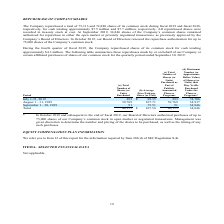From Amcon Distributing's financial document, How many shares of its common stock did the company repurchase in fiscal 2019 and fiscal 2018, respectively? The document shows two values: 75,113 and 74,880. From the document: "The Company repurchased a total of 75,113 and 74,880 shares of its common stock during fiscal 2019 and fiscal 2018, respectively, for cash totaling ap..." Also, How much did the company pay to repurchase shares of its common stock during fiscal 2019 and fiscal 2018, respectively? The document shows two values: $7.5 million and $7.7 million. From the document: ", for cash totaling approximately $7.5 million and $7.7 million, respectively. All repurchased shares were recorded in treasury stock at cost. At Sept..." Also, What is the total number of shares purchased by the company in August and September 2019 respectively? The document shows two values: 39,769 and 91. From the document: "August 1 - 31, 2019 39,769 107.71 39,769 34,937 September 1 - 30, 2019 91 75.51 91 34,846 Total 40,153 $ 107.58 40,153 34,846..." Also, can you calculate: What is the percentage change in the shares of common stock repurchased between fiscal 2018 and 2019? To answer this question, I need to perform calculations using the financial data. The calculation is: (75,113 - 74,880)/74,880 , which equals 0.31 (percentage). This is based on the information: "The Company repurchased a total of 75,113 and 74,880 shares of its common stock during fiscal 2019 and fiscal 2018, respectively, for cash totaling appr The Company repurchased a total of 75,113 and 7..." The key data points involved are: 74,880, 75,113. Also, can you calculate: What is the percentage change in the amount paid by the company to purchase its common stock during 2018 and 2019? To answer this question, I need to perform calculations using the financial data. The calculation is: (7.5 - 7.7)/7.7 , which equals -2.6 (percentage). This is based on the information: "for cash totaling approximately $7.5 million and $7.7 million, respectively. All repurchased shares were recorded in treasury stock at cost. At September 8, respectively, for cash totaling approximate..." The key data points involved are: 7.5, 7.7. Also, can you calculate: What is the percentage change in the number of shares (or units) purchased by the company between August and September 2019? To answer this question, I need to perform calculations using the financial data. The calculation is: (91 - 39,769)/39,769 , which equals -99.77 (percentage). This is based on the information: "August 1 - 31, 2019 39,769 107.71 39,769 34,937 September 1 - 30, 2019 91 75.51 91 34,846 Total 40,153 $ 107.58 40,153 34,846..." The key data points involved are: 39,769, 91. 